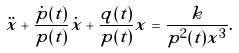<formula> <loc_0><loc_0><loc_500><loc_500>\ddot { x } + \frac { \dot { p } ( t ) } { p ( t ) } \dot { x } + \frac { q ( t ) } { p ( t ) } x = \frac { k } { p ^ { 2 } ( t ) x ^ { 3 } } .</formula> 